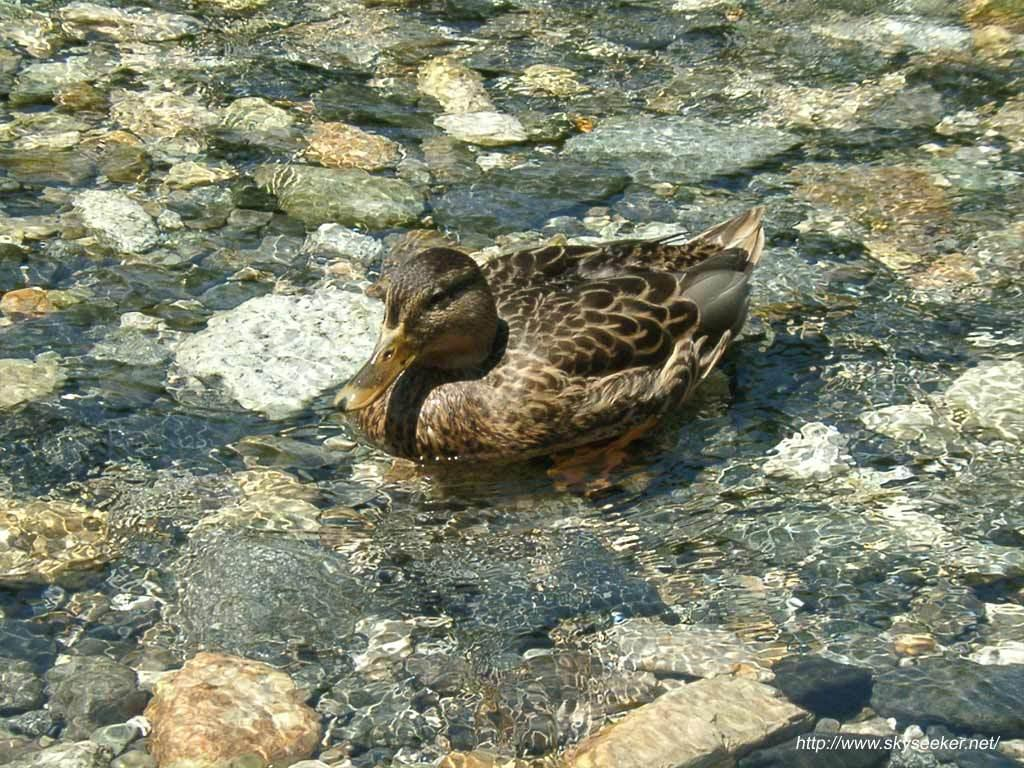What type of animal is in the image? There is a bird in the image. Where is the bird located? The bird is on the water. What can be seen in the background of the image? There are rocks visible in the background of the image. Is there any text present in the image? Yes, there is some text in the bottom right corner of the image. What type of cloud is present in the image? There is no cloud present in the image; it features a bird on the water with rocks in the background and text in the corner. 